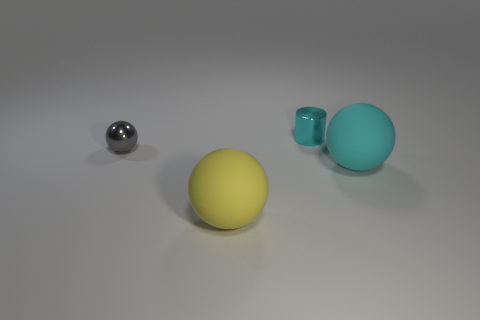There is a sphere that is the same size as the cyan shiny thing; what is it made of?
Ensure brevity in your answer.  Metal. What number of things are either metal things on the right side of the big yellow object or blue matte things?
Provide a succinct answer. 1. Are any brown rubber cylinders visible?
Offer a very short reply. No. What is the cyan thing to the right of the tiny cylinder made of?
Provide a short and direct response. Rubber. There is a big thing that is the same color as the tiny metal cylinder; what is it made of?
Your response must be concise. Rubber. How many big objects are either cyan cylinders or metallic spheres?
Give a very brief answer. 0. What is the color of the tiny metallic cylinder?
Make the answer very short. Cyan. Is there a matte thing left of the big rubber object that is to the right of the shiny cylinder?
Ensure brevity in your answer.  Yes. Are there fewer large cyan spheres on the right side of the cyan metal cylinder than tiny green matte spheres?
Your response must be concise. No. Are the big thing that is in front of the big cyan ball and the tiny cyan cylinder made of the same material?
Make the answer very short. No. 